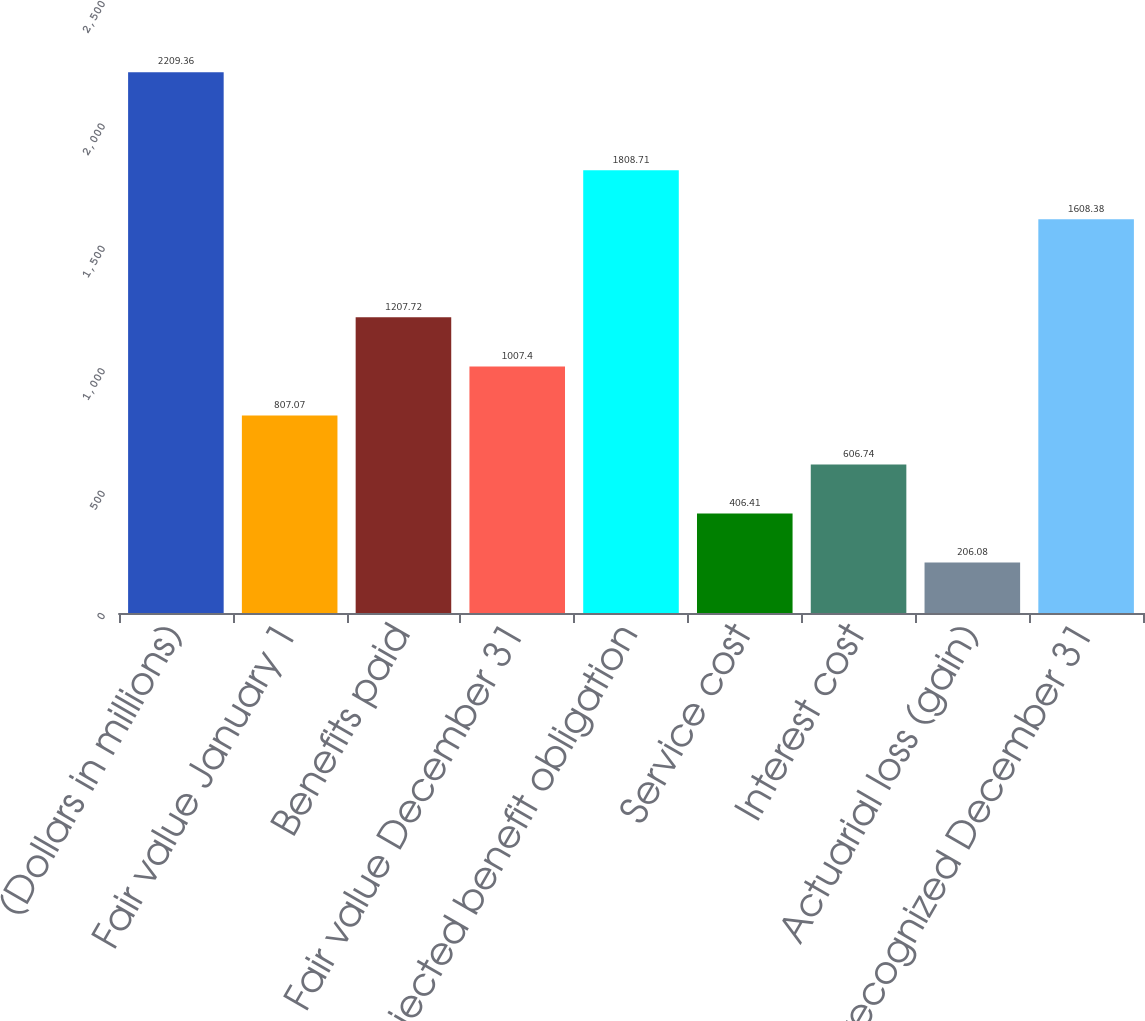Convert chart. <chart><loc_0><loc_0><loc_500><loc_500><bar_chart><fcel>(Dollars in millions)<fcel>Fair value January 1<fcel>Benefits paid<fcel>Fair value December 31<fcel>Projected benefit obligation<fcel>Service cost<fcel>Interest cost<fcel>Actuarial loss (gain)<fcel>Amount recognized December 31<nl><fcel>2209.36<fcel>807.07<fcel>1207.72<fcel>1007.4<fcel>1808.71<fcel>406.41<fcel>606.74<fcel>206.08<fcel>1608.38<nl></chart> 